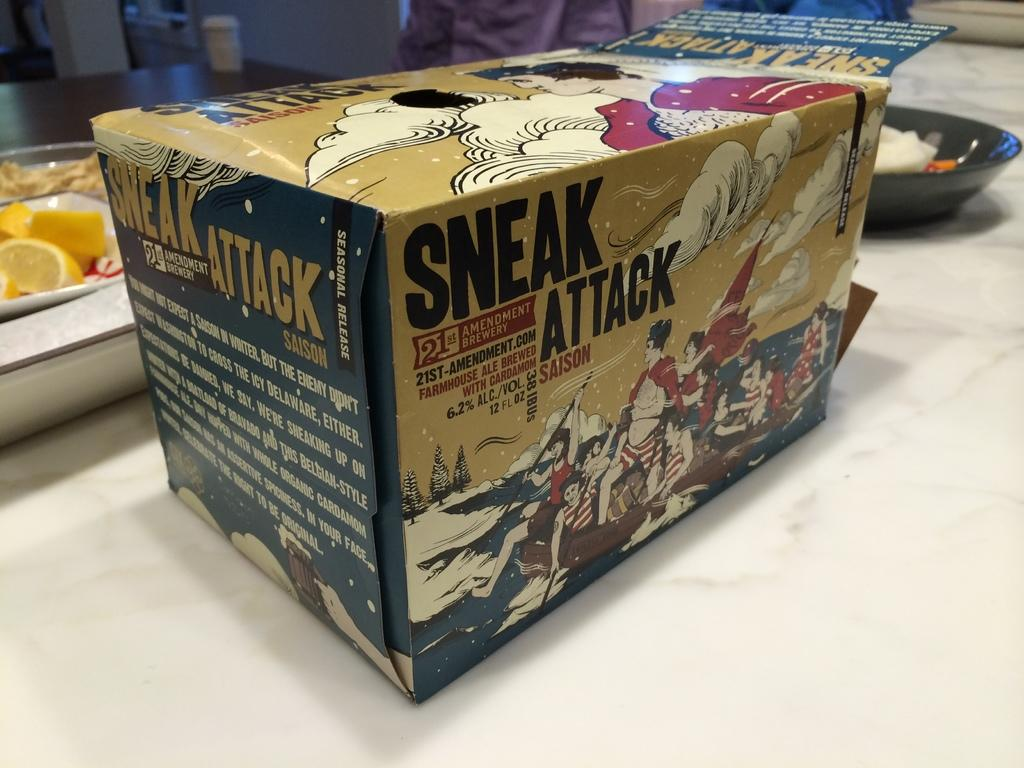<image>
Present a compact description of the photo's key features. A case of twelve bottles of Sneak Attack beer. 